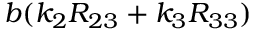<formula> <loc_0><loc_0><loc_500><loc_500>b ( k _ { 2 } R _ { 2 3 } + k _ { 3 } R _ { 3 3 } )</formula> 